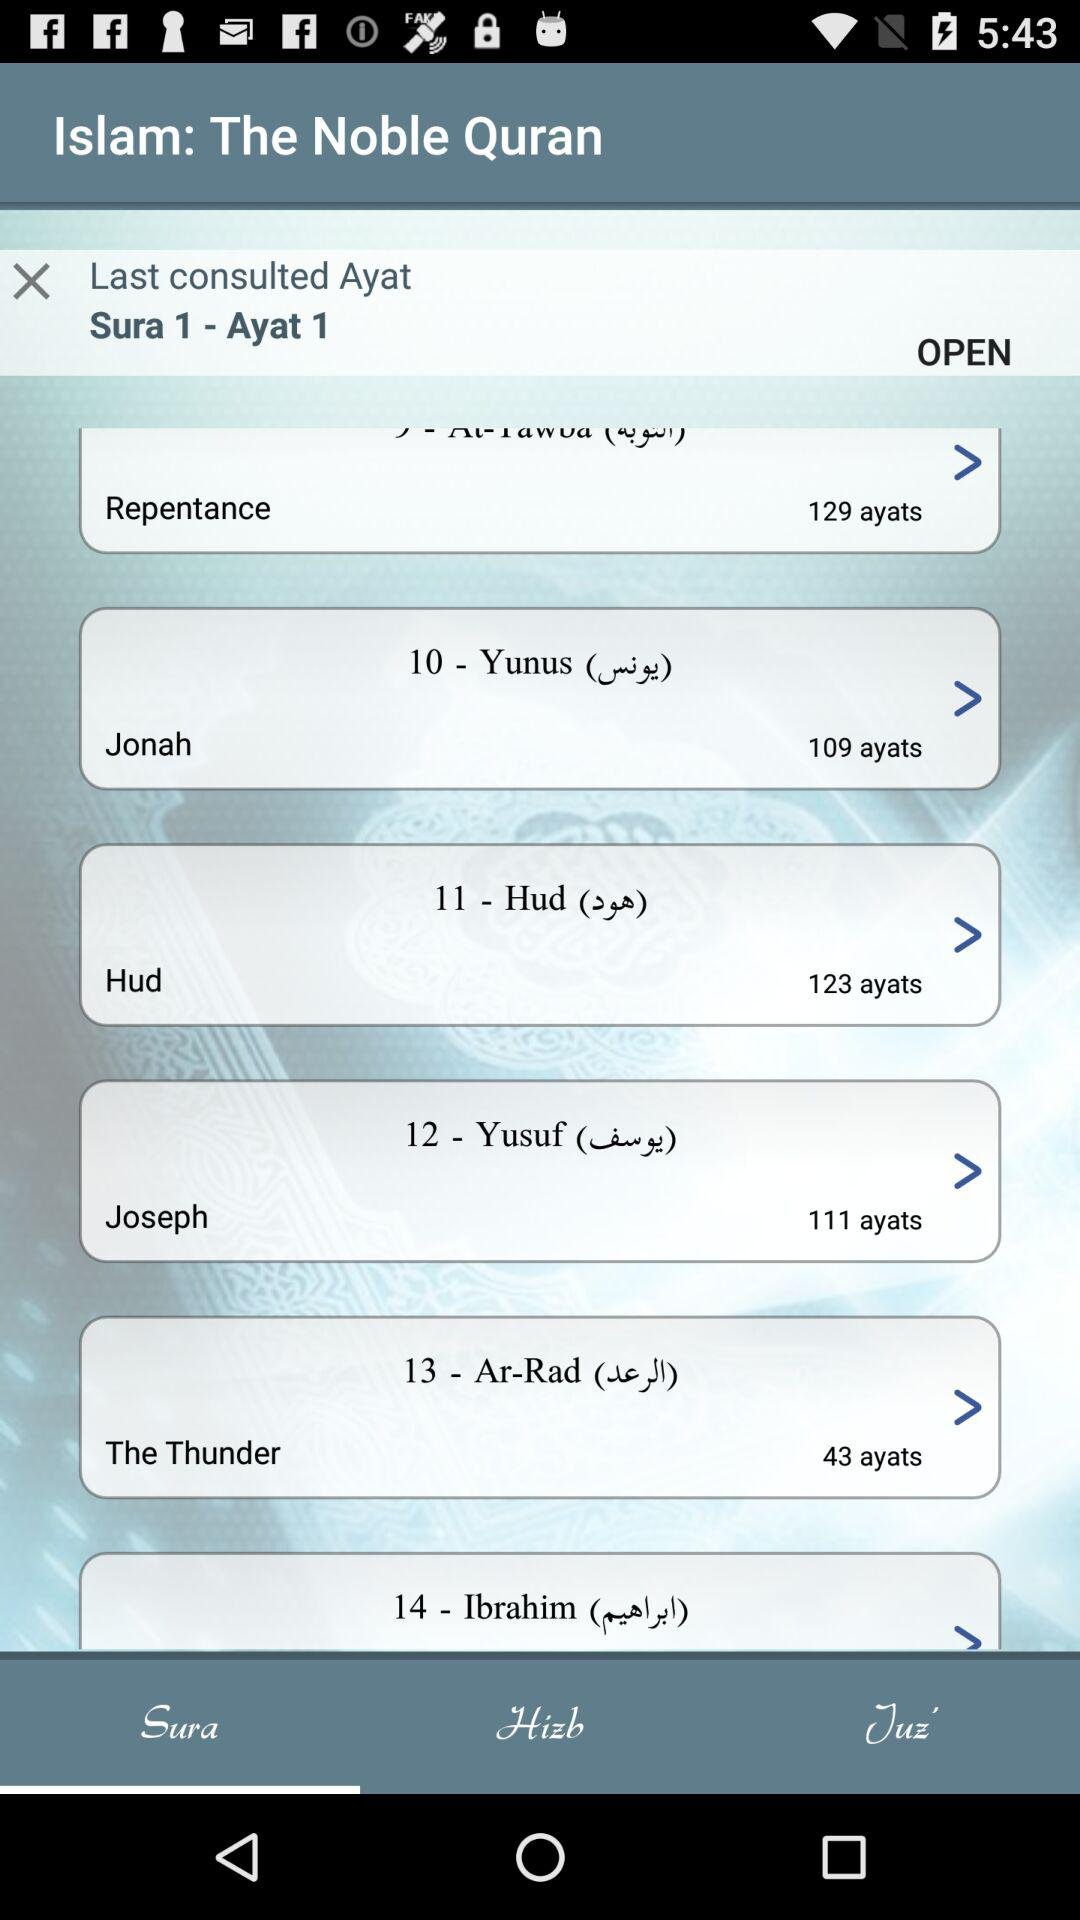How many ayats are there in "Joseph"? There are 111 ayats in "Joseph". 